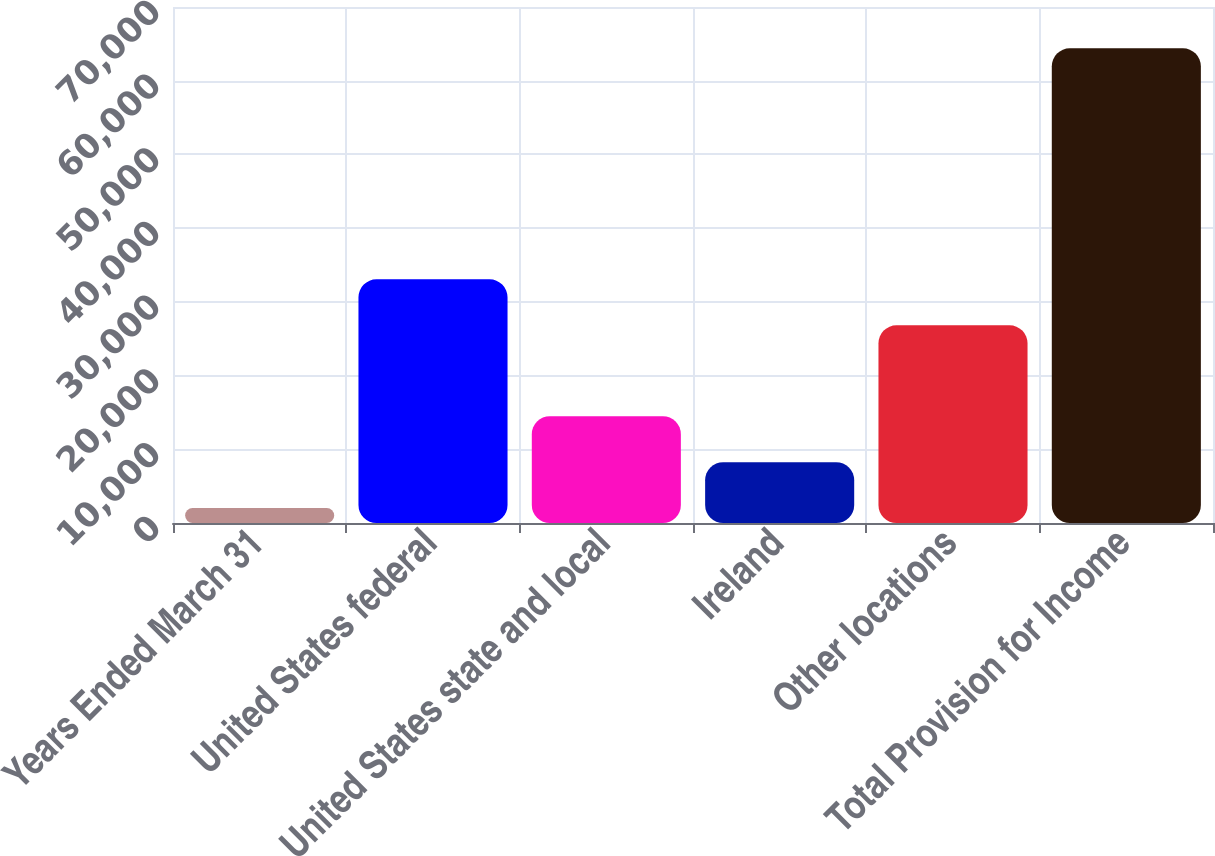Convert chart. <chart><loc_0><loc_0><loc_500><loc_500><bar_chart><fcel>Years Ended March 31<fcel>United States federal<fcel>United States state and local<fcel>Ireland<fcel>Other locations<fcel>Total Provision for Income<nl><fcel>2019<fcel>33061.5<fcel>14494<fcel>8256.5<fcel>26824<fcel>64394<nl></chart> 